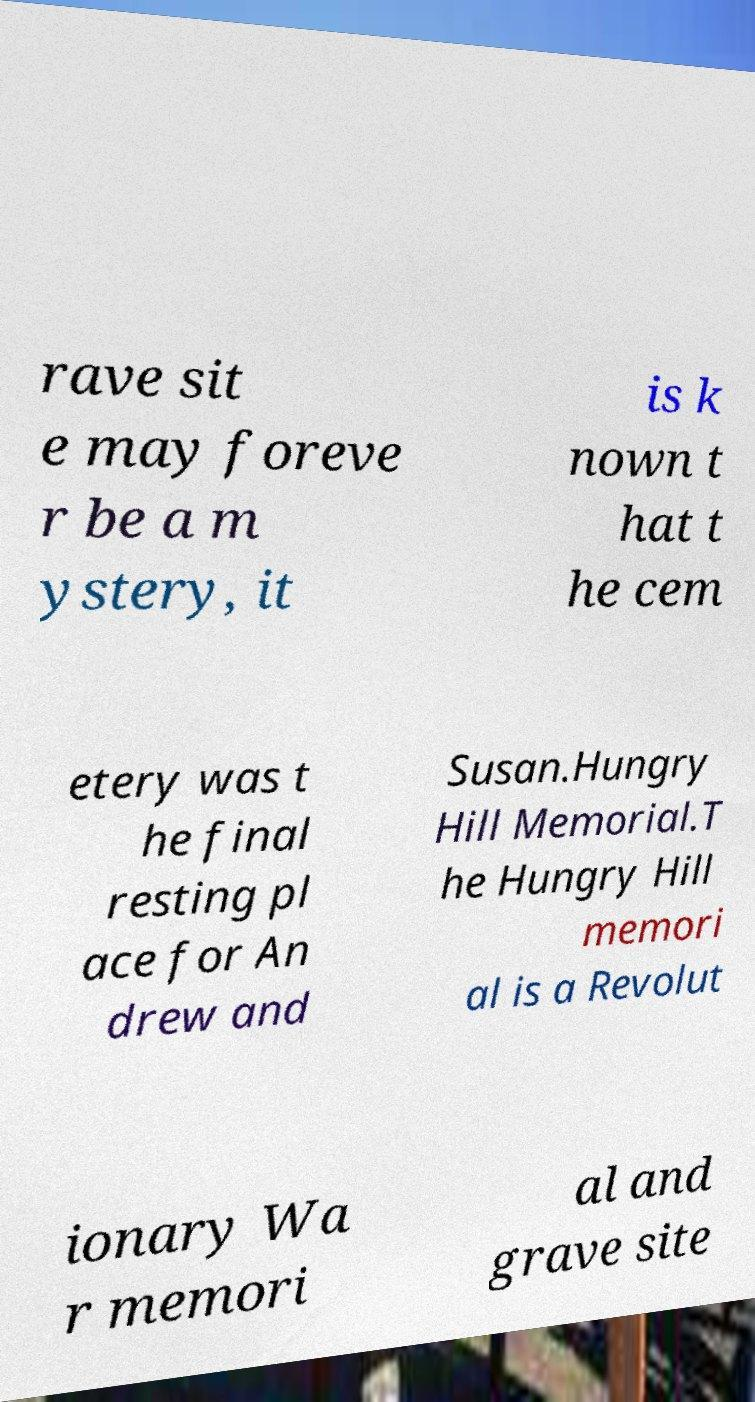Can you accurately transcribe the text from the provided image for me? rave sit e may foreve r be a m ystery, it is k nown t hat t he cem etery was t he final resting pl ace for An drew and Susan.Hungry Hill Memorial.T he Hungry Hill memori al is a Revolut ionary Wa r memori al and grave site 